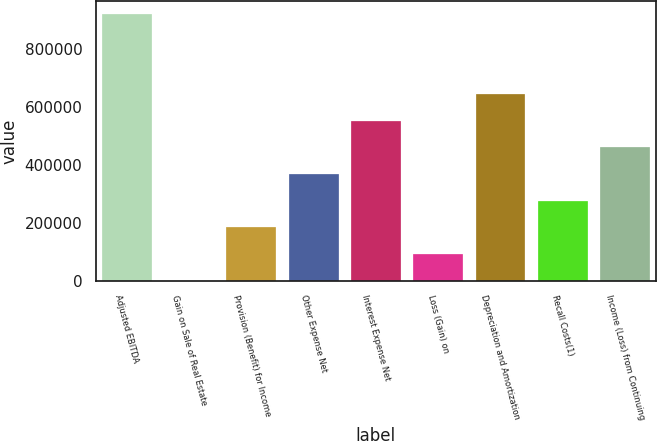Convert chart to OTSL. <chart><loc_0><loc_0><loc_500><loc_500><bar_chart><fcel>Adjusted EBITDA<fcel>Gain on Sale of Real Estate<fcel>Provision (Benefit) for Income<fcel>Other Expense Net<fcel>Interest Expense Net<fcel>Loss (Gain) on<fcel>Depreciation and Amortization<fcel>Recall Costs(1)<fcel>Income (Loss) from Continuing<nl><fcel>920005<fcel>850<fcel>184681<fcel>368512<fcel>552343<fcel>92765.5<fcel>644258<fcel>276596<fcel>460428<nl></chart> 